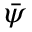Convert formula to latex. <formula><loc_0><loc_0><loc_500><loc_500>\bar { \psi }</formula> 